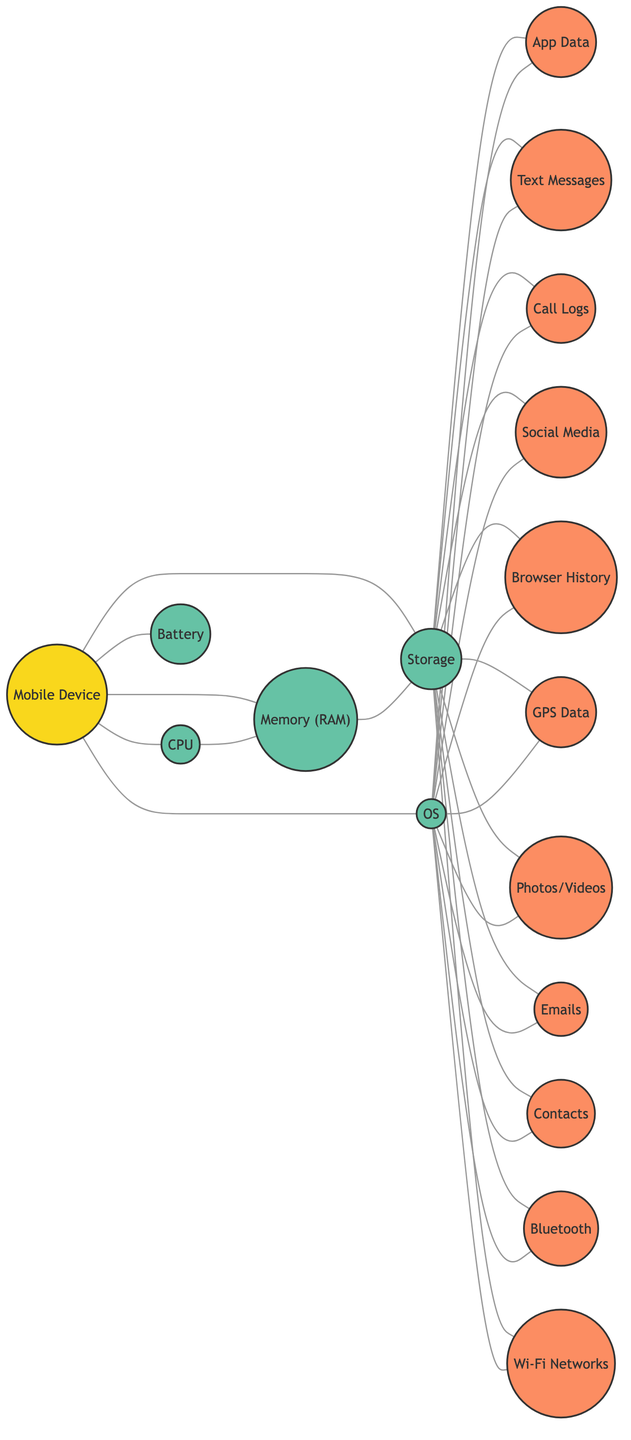How many nodes are in the diagram? The diagram contains a total of 17 nodes, which represent various components of the mobile device and potential evidence sources.
Answer: 17 Which component is directly connected to the Mobile Device? The Mobile Device is directly connected to five components: CPU, Memory (RAM), Storage, Battery, and Operating System.
Answer: CPU, Memory (RAM), Storage, Battery, Operating System What potential evidence sources are connected to Storage? The Storage component is connected to several potential evidence sources: App Data, Text Messages, Call Logs, Social Media Data, Browser History, GPS/Location Data, Photos and Videos, Emails, Contacts, Bluetooth Connections, and Wi-Fi Networks.
Answer: App Data, Text Messages, Call Logs, Social Media Data, Browser History, GPS/Location Data, Photos and Videos, Emails, Contacts, Bluetooth Connections, Wi-Fi Networks How many edges connect to the Operating System? The Operating System is connected to eleven edges, linking it to different potential evidence sources, indicating the various interactions it facilitates.
Answer: 11 Is there a connection between CPU and GPS/Location Data? There is no direct connection between the CPU and GPS/Location Data in the diagram as they are not linked directly by an edge.
Answer: No What is the relationship between Memory (RAM) and Storage? Memory (RAM) and Storage are directly connected in the diagram, indicating that they interact with each other for data processing and storage.
Answer: Directly connected How many types of data sources are linked to Storage? The Storage component links to ten types of data sources, which include App Data, Text Messages, Call Logs, Social Media Data, Browser History, GPS/Location Data, Photos and Videos, Emails, Contacts, and Bluetooth Connections, and Wi-Fi Networks.
Answer: 10 Which two nodes are connected by the most edges? The Storage node is connected to all potential evidence sources except the Battery, resulting in the most edges connected to it.
Answer: Storage and all potential evidence sources What is the maximum number of direct connections any single node has? The maximum number of direct connections is seen at the Storage node, which connects to ten different potential evidence sources.
Answer: 10 Are there any connections between layers of components? Yes, connections exist between the application layer (e.g., App Data) and the system layer (e.g., Operating System, Storage), indicating their interaction.
Answer: Yes 